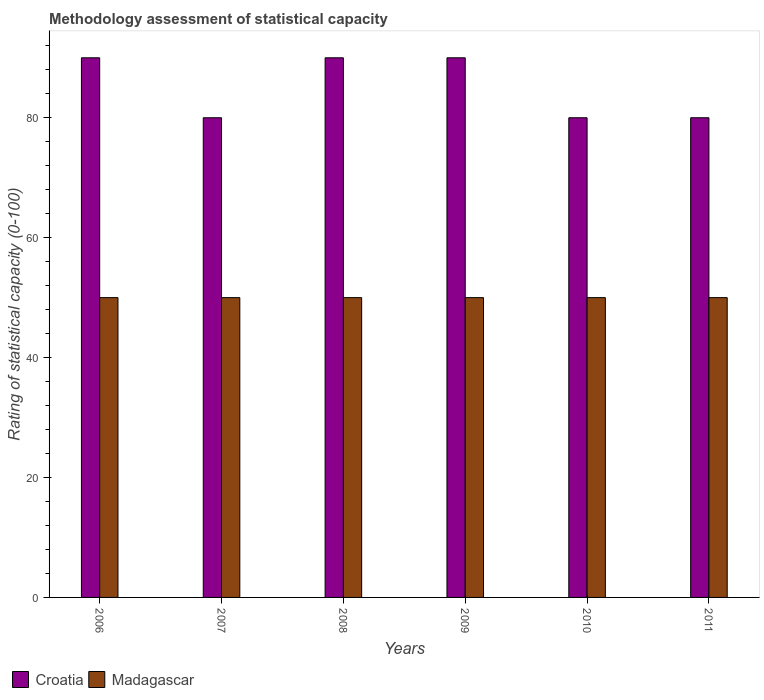How many different coloured bars are there?
Ensure brevity in your answer.  2. What is the label of the 3rd group of bars from the left?
Offer a terse response. 2008. In how many cases, is the number of bars for a given year not equal to the number of legend labels?
Your response must be concise. 0. What is the rating of statistical capacity in Madagascar in 2007?
Offer a terse response. 50. Across all years, what is the maximum rating of statistical capacity in Croatia?
Your answer should be compact. 90. Across all years, what is the minimum rating of statistical capacity in Madagascar?
Offer a terse response. 50. In which year was the rating of statistical capacity in Madagascar minimum?
Your answer should be compact. 2006. What is the total rating of statistical capacity in Madagascar in the graph?
Make the answer very short. 300. What is the difference between the rating of statistical capacity in Croatia in 2009 and the rating of statistical capacity in Madagascar in 2006?
Offer a very short reply. 40. What is the average rating of statistical capacity in Madagascar per year?
Provide a short and direct response. 50. In the year 2011, what is the difference between the rating of statistical capacity in Madagascar and rating of statistical capacity in Croatia?
Provide a succinct answer. -30. In how many years, is the rating of statistical capacity in Croatia greater than 60?
Give a very brief answer. 6. What is the ratio of the rating of statistical capacity in Croatia in 2007 to that in 2009?
Provide a short and direct response. 0.89. Is the rating of statistical capacity in Croatia in 2008 less than that in 2009?
Your answer should be very brief. No. What is the difference between the highest and the second highest rating of statistical capacity in Madagascar?
Ensure brevity in your answer.  0. In how many years, is the rating of statistical capacity in Croatia greater than the average rating of statistical capacity in Croatia taken over all years?
Your response must be concise. 3. Is the sum of the rating of statistical capacity in Croatia in 2006 and 2007 greater than the maximum rating of statistical capacity in Madagascar across all years?
Keep it short and to the point. Yes. What does the 1st bar from the left in 2009 represents?
Make the answer very short. Croatia. What does the 2nd bar from the right in 2007 represents?
Make the answer very short. Croatia. How many bars are there?
Provide a short and direct response. 12. Are all the bars in the graph horizontal?
Ensure brevity in your answer.  No. What is the difference between two consecutive major ticks on the Y-axis?
Your answer should be very brief. 20. Are the values on the major ticks of Y-axis written in scientific E-notation?
Your answer should be compact. No. Does the graph contain grids?
Provide a succinct answer. No. Where does the legend appear in the graph?
Your answer should be compact. Bottom left. How many legend labels are there?
Your answer should be compact. 2. What is the title of the graph?
Offer a very short reply. Methodology assessment of statistical capacity. What is the label or title of the Y-axis?
Ensure brevity in your answer.  Rating of statistical capacity (0-100). What is the Rating of statistical capacity (0-100) of Madagascar in 2008?
Your answer should be compact. 50. What is the Rating of statistical capacity (0-100) in Croatia in 2010?
Provide a succinct answer. 80. What is the Rating of statistical capacity (0-100) of Croatia in 2011?
Your response must be concise. 80. Across all years, what is the maximum Rating of statistical capacity (0-100) of Madagascar?
Offer a very short reply. 50. Across all years, what is the minimum Rating of statistical capacity (0-100) of Madagascar?
Provide a succinct answer. 50. What is the total Rating of statistical capacity (0-100) in Croatia in the graph?
Provide a succinct answer. 510. What is the total Rating of statistical capacity (0-100) in Madagascar in the graph?
Offer a terse response. 300. What is the difference between the Rating of statistical capacity (0-100) of Madagascar in 2006 and that in 2007?
Offer a terse response. 0. What is the difference between the Rating of statistical capacity (0-100) in Madagascar in 2006 and that in 2008?
Keep it short and to the point. 0. What is the difference between the Rating of statistical capacity (0-100) of Madagascar in 2006 and that in 2009?
Your answer should be compact. 0. What is the difference between the Rating of statistical capacity (0-100) in Croatia in 2006 and that in 2011?
Ensure brevity in your answer.  10. What is the difference between the Rating of statistical capacity (0-100) in Madagascar in 2006 and that in 2011?
Offer a terse response. 0. What is the difference between the Rating of statistical capacity (0-100) of Madagascar in 2007 and that in 2008?
Make the answer very short. 0. What is the difference between the Rating of statistical capacity (0-100) in Croatia in 2007 and that in 2009?
Your answer should be very brief. -10. What is the difference between the Rating of statistical capacity (0-100) in Madagascar in 2007 and that in 2009?
Your answer should be very brief. 0. What is the difference between the Rating of statistical capacity (0-100) of Croatia in 2007 and that in 2010?
Give a very brief answer. 0. What is the difference between the Rating of statistical capacity (0-100) of Madagascar in 2007 and that in 2011?
Your response must be concise. 0. What is the difference between the Rating of statistical capacity (0-100) in Madagascar in 2008 and that in 2009?
Give a very brief answer. 0. What is the difference between the Rating of statistical capacity (0-100) of Croatia in 2008 and that in 2010?
Keep it short and to the point. 10. What is the difference between the Rating of statistical capacity (0-100) in Croatia in 2008 and that in 2011?
Make the answer very short. 10. What is the difference between the Rating of statistical capacity (0-100) in Croatia in 2009 and that in 2011?
Ensure brevity in your answer.  10. What is the difference between the Rating of statistical capacity (0-100) of Croatia in 2010 and that in 2011?
Ensure brevity in your answer.  0. What is the difference between the Rating of statistical capacity (0-100) in Croatia in 2006 and the Rating of statistical capacity (0-100) in Madagascar in 2007?
Provide a short and direct response. 40. What is the difference between the Rating of statistical capacity (0-100) in Croatia in 2006 and the Rating of statistical capacity (0-100) in Madagascar in 2009?
Ensure brevity in your answer.  40. What is the difference between the Rating of statistical capacity (0-100) of Croatia in 2007 and the Rating of statistical capacity (0-100) of Madagascar in 2009?
Provide a succinct answer. 30. What is the difference between the Rating of statistical capacity (0-100) of Croatia in 2007 and the Rating of statistical capacity (0-100) of Madagascar in 2010?
Give a very brief answer. 30. What is the difference between the Rating of statistical capacity (0-100) in Croatia in 2009 and the Rating of statistical capacity (0-100) in Madagascar in 2011?
Offer a terse response. 40. What is the difference between the Rating of statistical capacity (0-100) of Croatia in 2010 and the Rating of statistical capacity (0-100) of Madagascar in 2011?
Offer a terse response. 30. What is the average Rating of statistical capacity (0-100) of Madagascar per year?
Keep it short and to the point. 50. In the year 2006, what is the difference between the Rating of statistical capacity (0-100) of Croatia and Rating of statistical capacity (0-100) of Madagascar?
Give a very brief answer. 40. In the year 2007, what is the difference between the Rating of statistical capacity (0-100) of Croatia and Rating of statistical capacity (0-100) of Madagascar?
Provide a short and direct response. 30. In the year 2008, what is the difference between the Rating of statistical capacity (0-100) in Croatia and Rating of statistical capacity (0-100) in Madagascar?
Provide a succinct answer. 40. In the year 2010, what is the difference between the Rating of statistical capacity (0-100) of Croatia and Rating of statistical capacity (0-100) of Madagascar?
Make the answer very short. 30. What is the ratio of the Rating of statistical capacity (0-100) of Croatia in 2006 to that in 2007?
Provide a short and direct response. 1.12. What is the ratio of the Rating of statistical capacity (0-100) of Croatia in 2006 to that in 2008?
Make the answer very short. 1. What is the ratio of the Rating of statistical capacity (0-100) of Madagascar in 2006 to that in 2008?
Ensure brevity in your answer.  1. What is the ratio of the Rating of statistical capacity (0-100) in Madagascar in 2006 to that in 2011?
Your response must be concise. 1. What is the ratio of the Rating of statistical capacity (0-100) in Croatia in 2007 to that in 2008?
Keep it short and to the point. 0.89. What is the ratio of the Rating of statistical capacity (0-100) of Croatia in 2007 to that in 2009?
Ensure brevity in your answer.  0.89. What is the ratio of the Rating of statistical capacity (0-100) of Croatia in 2007 to that in 2011?
Give a very brief answer. 1. What is the ratio of the Rating of statistical capacity (0-100) in Madagascar in 2007 to that in 2011?
Provide a succinct answer. 1. What is the ratio of the Rating of statistical capacity (0-100) of Croatia in 2008 to that in 2009?
Your answer should be compact. 1. What is the ratio of the Rating of statistical capacity (0-100) of Madagascar in 2008 to that in 2009?
Provide a succinct answer. 1. What is the ratio of the Rating of statistical capacity (0-100) of Croatia in 2008 to that in 2011?
Give a very brief answer. 1.12. What is the ratio of the Rating of statistical capacity (0-100) of Madagascar in 2009 to that in 2010?
Provide a short and direct response. 1. What is the ratio of the Rating of statistical capacity (0-100) in Croatia in 2009 to that in 2011?
Keep it short and to the point. 1.12. What is the ratio of the Rating of statistical capacity (0-100) of Madagascar in 2009 to that in 2011?
Provide a succinct answer. 1. What is the ratio of the Rating of statistical capacity (0-100) in Croatia in 2010 to that in 2011?
Offer a terse response. 1. What is the ratio of the Rating of statistical capacity (0-100) of Madagascar in 2010 to that in 2011?
Keep it short and to the point. 1. What is the difference between the highest and the second highest Rating of statistical capacity (0-100) in Madagascar?
Your response must be concise. 0. What is the difference between the highest and the lowest Rating of statistical capacity (0-100) of Madagascar?
Keep it short and to the point. 0. 